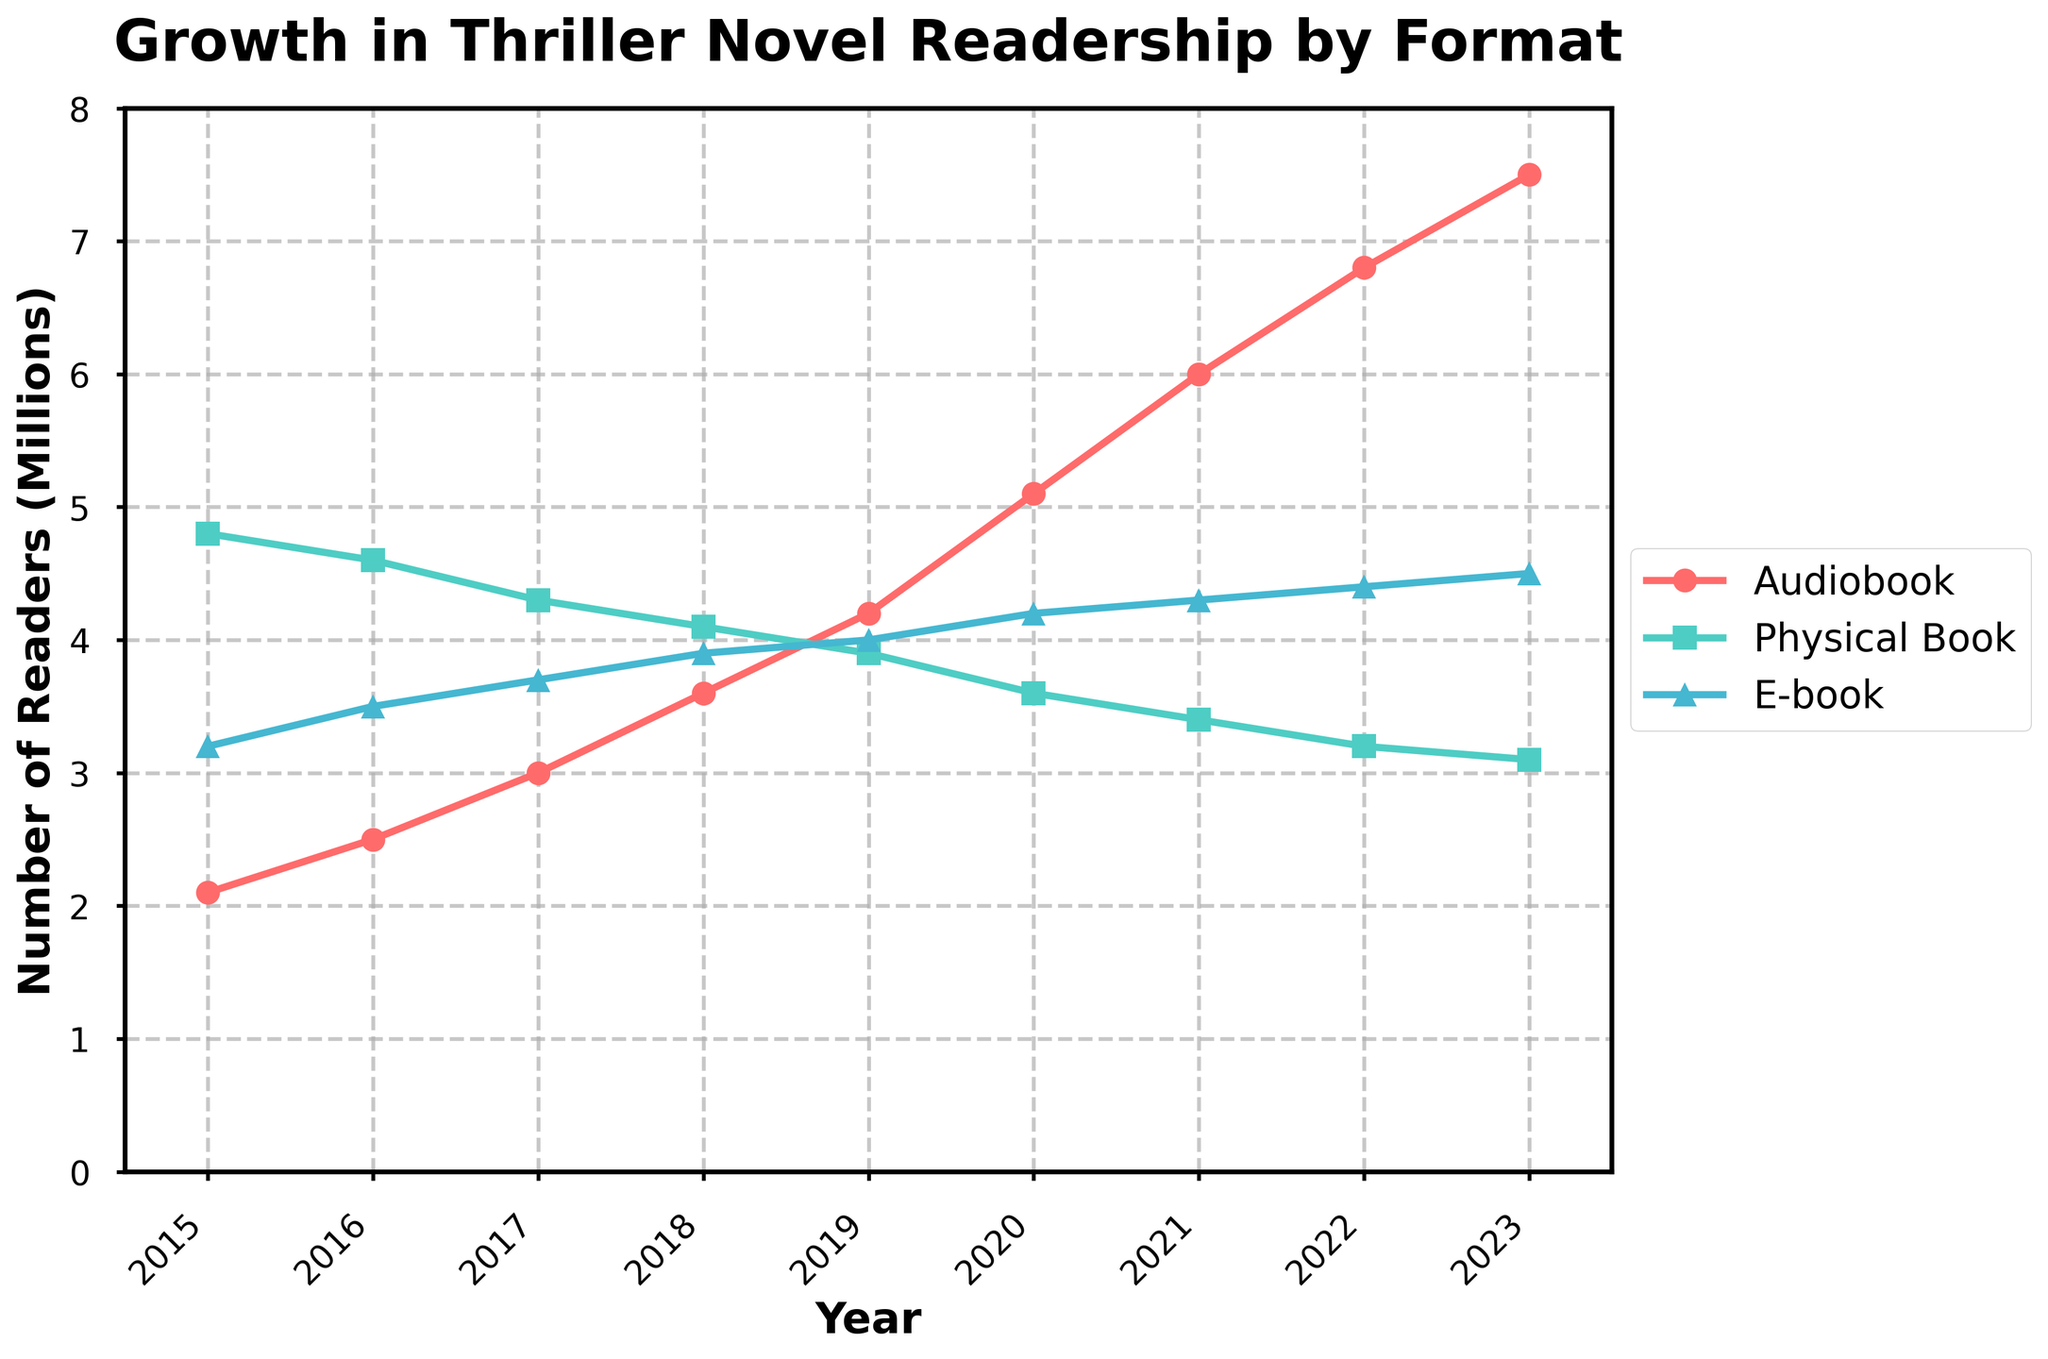How has the number of audiobook listeners compared to physical book readers changed over time? From 2015 to 2023, the number of audiobook listeners has consistently increased from 2.1 million to 7.5 million, while the number of physical book readers has steadily dropped from 4.8 million to 3.1 million.
Answer: Audiobook listeners increased, physical book readers decreased Which year saw the highest number of e-book readers? The highest number of e-book readers is observed in 2023 at 4.5 million.
Answer: 2023 How does the growth from 2015 to 2023 compare between audiobook listeners and e-book readers? Audiobook listeners grew from 2.1 million in 2015 to 7.5 million in 2023, an increase of 5.4 million. E-book readers grew from 3.2 million in 2015 to 4.5 million in 2023, an increase of 1.3 million.
Answer: Audiobook listeners grew by 5.4 million, e-book readers by 1.3 million Between which two consecutive years did audiobook listeners experience the highest growth rate? The highest growth rate for audiobook listeners was between 2019 and 2020, where the number increased from 4.2 million to 5.1 million, a growth of 0.9 million.
Answer: Between 2019 and 2020 What is the most noticeable trend in the number of physical book readers over the period shown? The most noticeable trend is a continuous decline in the number of physical book readers from 4.8 million in 2015 to 3.1 million in 2023.
Answer: Continuous decline By how much did the number of audiobook listeners exceed the number of physical book readers in 2023? In 2023, audiobook listeners were 7.5 million, and physical book readers were 3.1 million. The difference is 7.5 - 3.1 = 4.4 million.
Answer: 4.4 million In which year did e-book readers surpass physical book readers, and by how much? E-book readers surpassed physical book readers in 2019. In 2019, e-book readers were 4.0 million, and physical book readers were 3.9 million. The difference is 4.0 - 3.9 = 0.1 million.
Answer: 2019, by 0.1 million What general conclusion can be drawn about the popularity of audiobooks, physical books, and e-books from 2015 to 2023? The popularity of audiobooks has increased substantially while physical book readership has declined. E-book readership has seen a steady but smaller increase.
Answer: Audiobooks up, physical books down, e-books steady increase What is the average number of audiobook listeners from 2015 to 2023? The sum of audiobook listeners from 2015 to 2023 is 2.1 + 2.5 + 3.0 + 3.6 + 4.2 + 5.1 + 6.0 + 6.8 + 7.5 = 40.8 million. The number of years is 9. So, the average is 40.8 / 9 = about 4.53 million.
Answer: ~4.53 million 